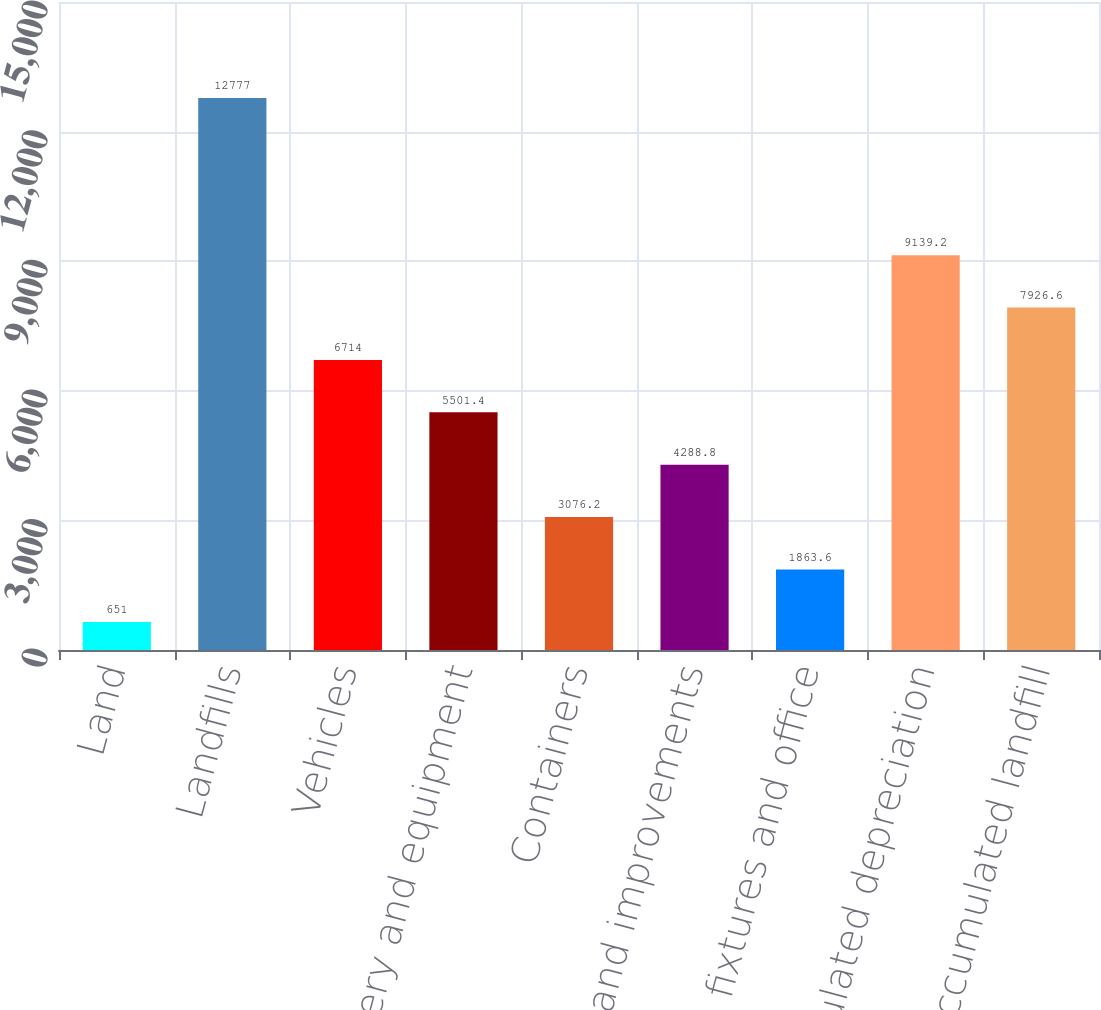Convert chart to OTSL. <chart><loc_0><loc_0><loc_500><loc_500><bar_chart><fcel>Land<fcel>Landfills<fcel>Vehicles<fcel>Machinery and equipment<fcel>Containers<fcel>Buildings and improvements<fcel>Furniture fixtures and office<fcel>Less accumulated depreciation<fcel>Less accumulated landfill<nl><fcel>651<fcel>12777<fcel>6714<fcel>5501.4<fcel>3076.2<fcel>4288.8<fcel>1863.6<fcel>9139.2<fcel>7926.6<nl></chart> 